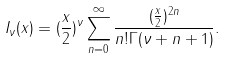Convert formula to latex. <formula><loc_0><loc_0><loc_500><loc_500>I _ { \nu } ( x ) = ( \frac { x } { 2 } ) ^ { \nu } \sum _ { n = 0 } ^ { \infty } \frac { ( \frac { x } { 2 } ) ^ { 2 n } } { n ! \Gamma ( \nu + n + 1 ) } .</formula> 